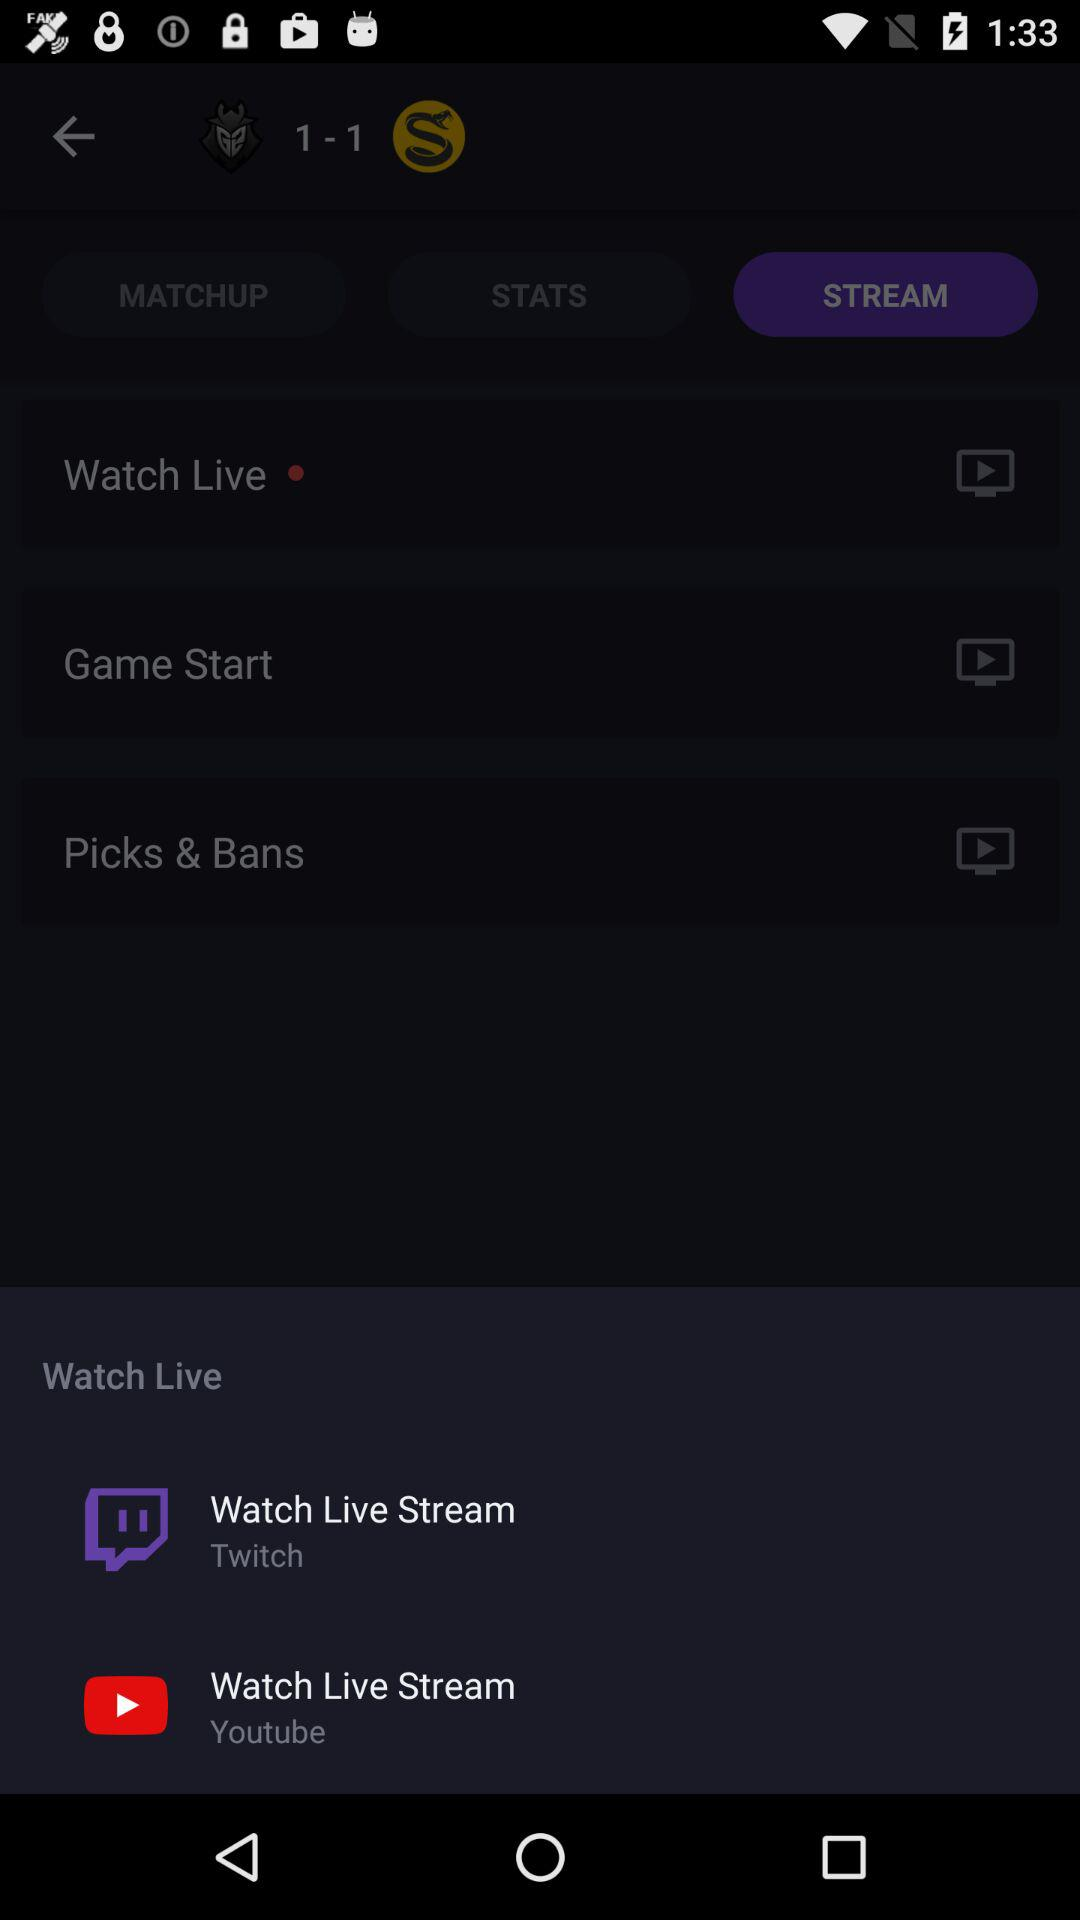Which applications can be used to watch live video? The applications that can be used to watch live video are "Twitch" and "Youtube". 